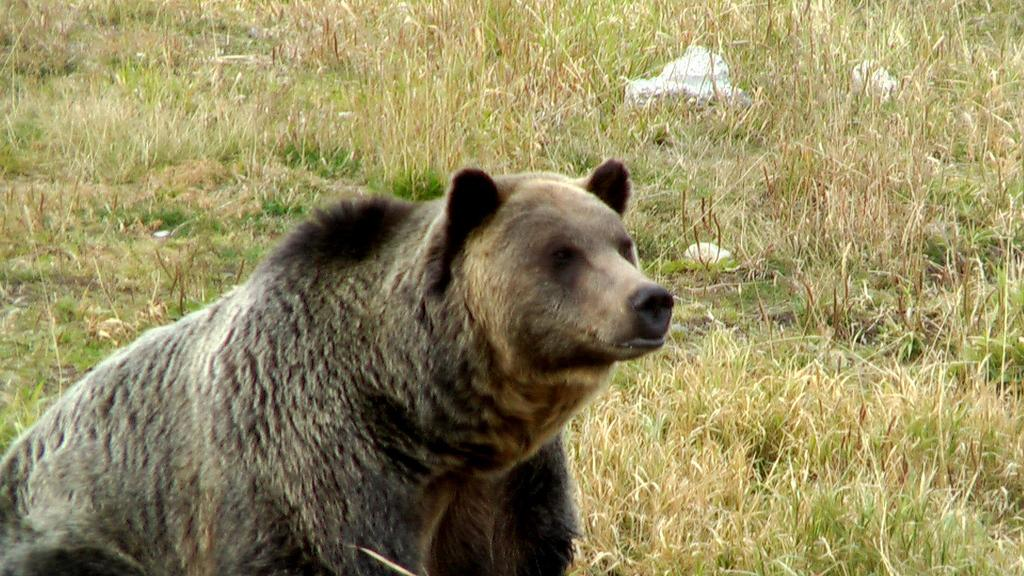What animal is present in the image? There is a bear in the image. Where is the bear located? The bear is on the ground. What type of vegetation can be seen in the background of the image? There is grass in the background of the image. How many dolls are sitting on the mailbox in the image? There are no dolls or mailboxes present in the image. 